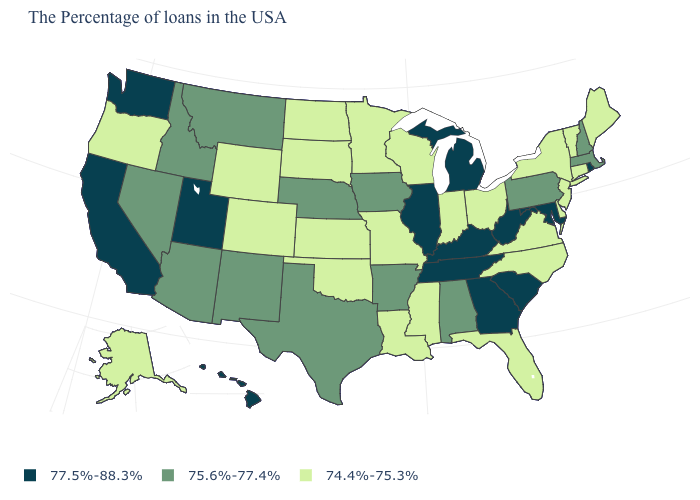Does California have the highest value in the West?
Short answer required. Yes. What is the lowest value in the USA?
Be succinct. 74.4%-75.3%. What is the value of Connecticut?
Keep it brief. 74.4%-75.3%. What is the value of New York?
Give a very brief answer. 74.4%-75.3%. Among the states that border Florida , which have the highest value?
Concise answer only. Georgia. What is the value of North Dakota?
Quick response, please. 74.4%-75.3%. What is the value of New York?
Be succinct. 74.4%-75.3%. What is the value of Wisconsin?
Answer briefly. 74.4%-75.3%. Does Illinois have the highest value in the MidWest?
Concise answer only. Yes. What is the lowest value in the USA?
Keep it brief. 74.4%-75.3%. What is the value of Maine?
Be succinct. 74.4%-75.3%. What is the value of Arizona?
Give a very brief answer. 75.6%-77.4%. What is the value of Kentucky?
Write a very short answer. 77.5%-88.3%. Among the states that border Iowa , which have the lowest value?
Keep it brief. Wisconsin, Missouri, Minnesota, South Dakota. What is the lowest value in the USA?
Write a very short answer. 74.4%-75.3%. 